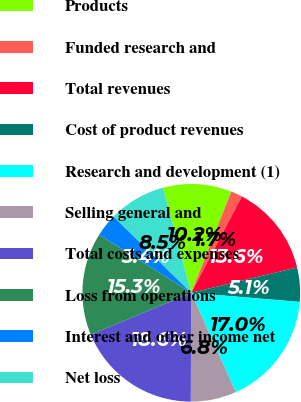Convert chart. <chart><loc_0><loc_0><loc_500><loc_500><pie_chart><fcel>Products<fcel>Funded research and<fcel>Total revenues<fcel>Cost of product revenues<fcel>Research and development (1)<fcel>Selling general and<fcel>Total costs and expenses<fcel>Loss from operations<fcel>Interest and other income net<fcel>Net loss<nl><fcel>10.17%<fcel>1.7%<fcel>13.56%<fcel>5.08%<fcel>16.95%<fcel>6.78%<fcel>18.64%<fcel>15.25%<fcel>3.39%<fcel>8.47%<nl></chart> 